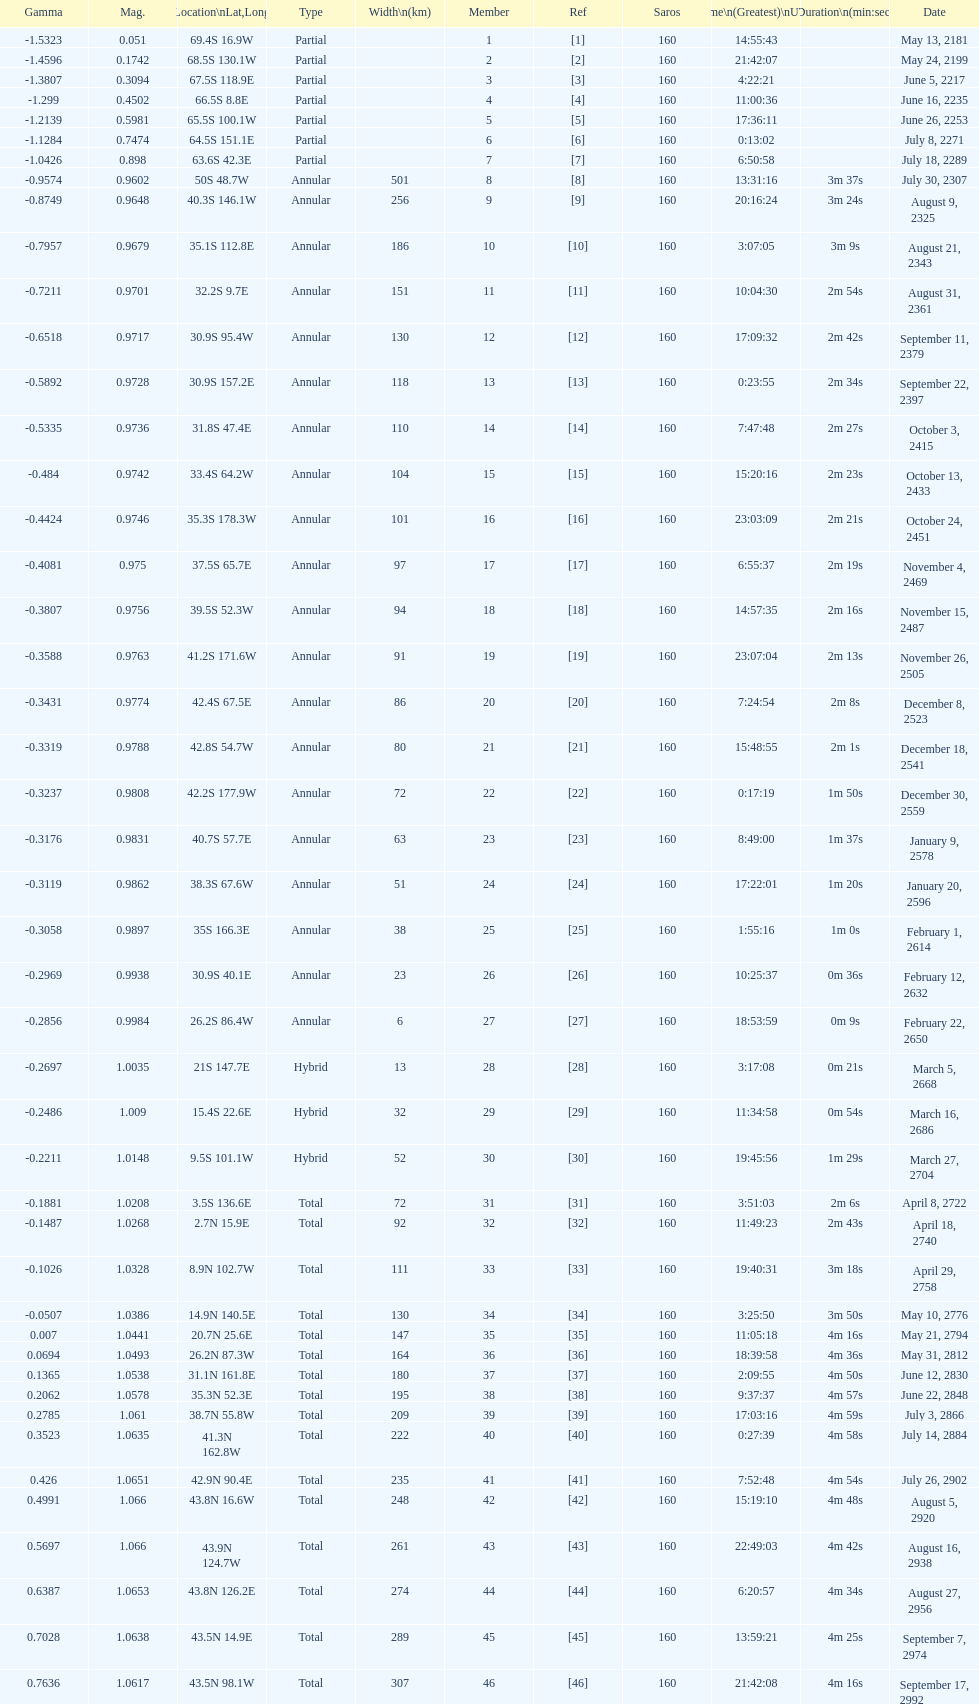Could you parse the entire table? {'header': ['Gamma', 'Mag.', 'Location\\nLat,Long', 'Type', 'Width\\n(km)', 'Member', 'Ref', 'Saros', 'Time\\n(Greatest)\\nUTC', 'Duration\\n(min:sec)', 'Date'], 'rows': [['-1.5323', '0.051', '69.4S 16.9W', 'Partial', '', '1', '[1]', '160', '14:55:43', '', 'May 13, 2181'], ['-1.4596', '0.1742', '68.5S 130.1W', 'Partial', '', '2', '[2]', '160', '21:42:07', '', 'May 24, 2199'], ['-1.3807', '0.3094', '67.5S 118.9E', 'Partial', '', '3', '[3]', '160', '4:22:21', '', 'June 5, 2217'], ['-1.299', '0.4502', '66.5S 8.8E', 'Partial', '', '4', '[4]', '160', '11:00:36', '', 'June 16, 2235'], ['-1.2139', '0.5981', '65.5S 100.1W', 'Partial', '', '5', '[5]', '160', '17:36:11', '', 'June 26, 2253'], ['-1.1284', '0.7474', '64.5S 151.1E', 'Partial', '', '6', '[6]', '160', '0:13:02', '', 'July 8, 2271'], ['-1.0426', '0.898', '63.6S 42.3E', 'Partial', '', '7', '[7]', '160', '6:50:58', '', 'July 18, 2289'], ['-0.9574', '0.9602', '50S 48.7W', 'Annular', '501', '8', '[8]', '160', '13:31:16', '3m 37s', 'July 30, 2307'], ['-0.8749', '0.9648', '40.3S 146.1W', 'Annular', '256', '9', '[9]', '160', '20:16:24', '3m 24s', 'August 9, 2325'], ['-0.7957', '0.9679', '35.1S 112.8E', 'Annular', '186', '10', '[10]', '160', '3:07:05', '3m 9s', 'August 21, 2343'], ['-0.7211', '0.9701', '32.2S 9.7E', 'Annular', '151', '11', '[11]', '160', '10:04:30', '2m 54s', 'August 31, 2361'], ['-0.6518', '0.9717', '30.9S 95.4W', 'Annular', '130', '12', '[12]', '160', '17:09:32', '2m 42s', 'September 11, 2379'], ['-0.5892', '0.9728', '30.9S 157.2E', 'Annular', '118', '13', '[13]', '160', '0:23:55', '2m 34s', 'September 22, 2397'], ['-0.5335', '0.9736', '31.8S 47.4E', 'Annular', '110', '14', '[14]', '160', '7:47:48', '2m 27s', 'October 3, 2415'], ['-0.484', '0.9742', '33.4S 64.2W', 'Annular', '104', '15', '[15]', '160', '15:20:16', '2m 23s', 'October 13, 2433'], ['-0.4424', '0.9746', '35.3S 178.3W', 'Annular', '101', '16', '[16]', '160', '23:03:09', '2m 21s', 'October 24, 2451'], ['-0.4081', '0.975', '37.5S 65.7E', 'Annular', '97', '17', '[17]', '160', '6:55:37', '2m 19s', 'November 4, 2469'], ['-0.3807', '0.9756', '39.5S 52.3W', 'Annular', '94', '18', '[18]', '160', '14:57:35', '2m 16s', 'November 15, 2487'], ['-0.3588', '0.9763', '41.2S 171.6W', 'Annular', '91', '19', '[19]', '160', '23:07:04', '2m 13s', 'November 26, 2505'], ['-0.3431', '0.9774', '42.4S 67.5E', 'Annular', '86', '20', '[20]', '160', '7:24:54', '2m 8s', 'December 8, 2523'], ['-0.3319', '0.9788', '42.8S 54.7W', 'Annular', '80', '21', '[21]', '160', '15:48:55', '2m 1s', 'December 18, 2541'], ['-0.3237', '0.9808', '42.2S 177.9W', 'Annular', '72', '22', '[22]', '160', '0:17:19', '1m 50s', 'December 30, 2559'], ['-0.3176', '0.9831', '40.7S 57.7E', 'Annular', '63', '23', '[23]', '160', '8:49:00', '1m 37s', 'January 9, 2578'], ['-0.3119', '0.9862', '38.3S 67.6W', 'Annular', '51', '24', '[24]', '160', '17:22:01', '1m 20s', 'January 20, 2596'], ['-0.3058', '0.9897', '35S 166.3E', 'Annular', '38', '25', '[25]', '160', '1:55:16', '1m 0s', 'February 1, 2614'], ['-0.2969', '0.9938', '30.9S 40.1E', 'Annular', '23', '26', '[26]', '160', '10:25:37', '0m 36s', 'February 12, 2632'], ['-0.2856', '0.9984', '26.2S 86.4W', 'Annular', '6', '27', '[27]', '160', '18:53:59', '0m 9s', 'February 22, 2650'], ['-0.2697', '1.0035', '21S 147.7E', 'Hybrid', '13', '28', '[28]', '160', '3:17:08', '0m 21s', 'March 5, 2668'], ['-0.2486', '1.009', '15.4S 22.6E', 'Hybrid', '32', '29', '[29]', '160', '11:34:58', '0m 54s', 'March 16, 2686'], ['-0.2211', '1.0148', '9.5S 101.1W', 'Hybrid', '52', '30', '[30]', '160', '19:45:56', '1m 29s', 'March 27, 2704'], ['-0.1881', '1.0208', '3.5S 136.6E', 'Total', '72', '31', '[31]', '160', '3:51:03', '2m 6s', 'April 8, 2722'], ['-0.1487', '1.0268', '2.7N 15.9E', 'Total', '92', '32', '[32]', '160', '11:49:23', '2m 43s', 'April 18, 2740'], ['-0.1026', '1.0328', '8.9N 102.7W', 'Total', '111', '33', '[33]', '160', '19:40:31', '3m 18s', 'April 29, 2758'], ['-0.0507', '1.0386', '14.9N 140.5E', 'Total', '130', '34', '[34]', '160', '3:25:50', '3m 50s', 'May 10, 2776'], ['0.007', '1.0441', '20.7N 25.6E', 'Total', '147', '35', '[35]', '160', '11:05:18', '4m 16s', 'May 21, 2794'], ['0.0694', '1.0493', '26.2N 87.3W', 'Total', '164', '36', '[36]', '160', '18:39:58', '4m 36s', 'May 31, 2812'], ['0.1365', '1.0538', '31.1N 161.8E', 'Total', '180', '37', '[37]', '160', '2:09:55', '4m 50s', 'June 12, 2830'], ['0.2062', '1.0578', '35.3N 52.3E', 'Total', '195', '38', '[38]', '160', '9:37:37', '4m 57s', 'June 22, 2848'], ['0.2785', '1.061', '38.7N 55.8W', 'Total', '209', '39', '[39]', '160', '17:03:16', '4m 59s', 'July 3, 2866'], ['0.3523', '1.0635', '41.3N 162.8W', 'Total', '222', '40', '[40]', '160', '0:27:39', '4m 58s', 'July 14, 2884'], ['0.426', '1.0651', '42.9N 90.4E', 'Total', '235', '41', '[41]', '160', '7:52:48', '4m 54s', 'July 26, 2902'], ['0.4991', '1.066', '43.8N 16.6W', 'Total', '248', '42', '[42]', '160', '15:19:10', '4m 48s', 'August 5, 2920'], ['0.5697', '1.066', '43.9N 124.7W', 'Total', '261', '43', '[43]', '160', '22:49:03', '4m 42s', 'August 16, 2938'], ['0.6387', '1.0653', '43.8N 126.2E', 'Total', '274', '44', '[44]', '160', '6:20:57', '4m 34s', 'August 27, 2956'], ['0.7028', '1.0638', '43.5N 14.9E', 'Total', '289', '45', '[45]', '160', '13:59:21', '4m 25s', 'September 7, 2974'], ['0.7636', '1.0617', '43.5N 98.1W', 'Total', '307', '46', '[46]', '160', '21:42:08', '4m 16s', 'September 17, 2992']]} Name a member number with a latitude above 60 s. 1. 